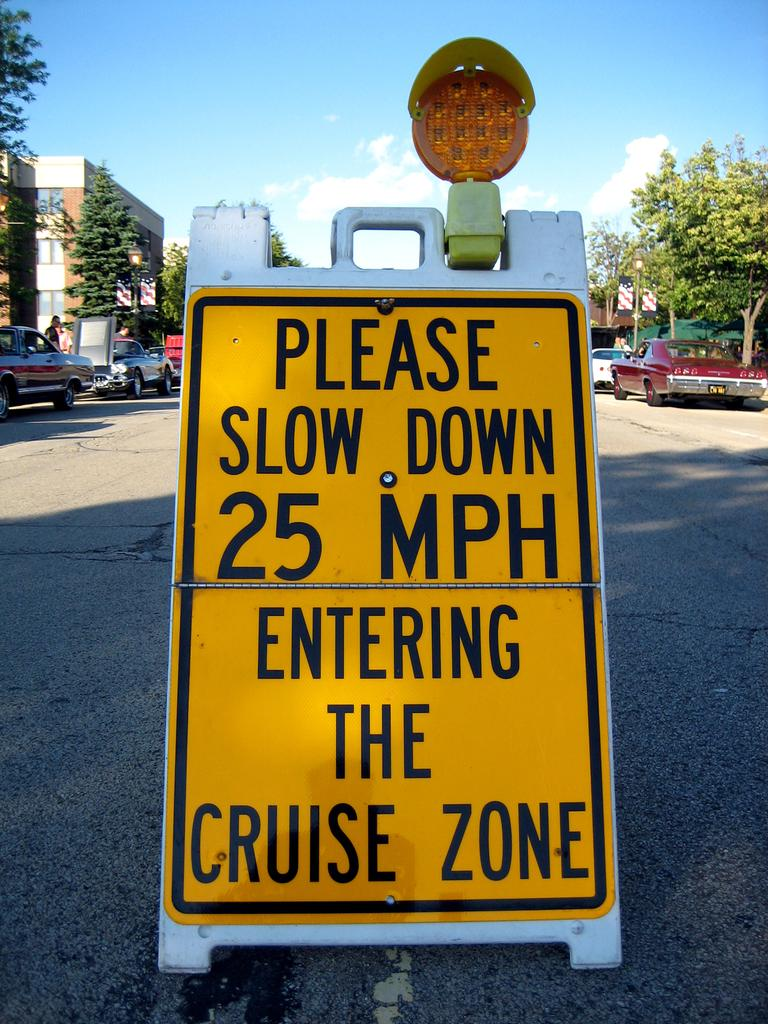<image>
Present a compact description of the photo's key features. A road sign says the speed limit is 25 MPH in the cruise zone. 